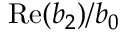Convert formula to latex. <formula><loc_0><loc_0><loc_500><loc_500>R e ( b _ { 2 } ) / b _ { 0 }</formula> 